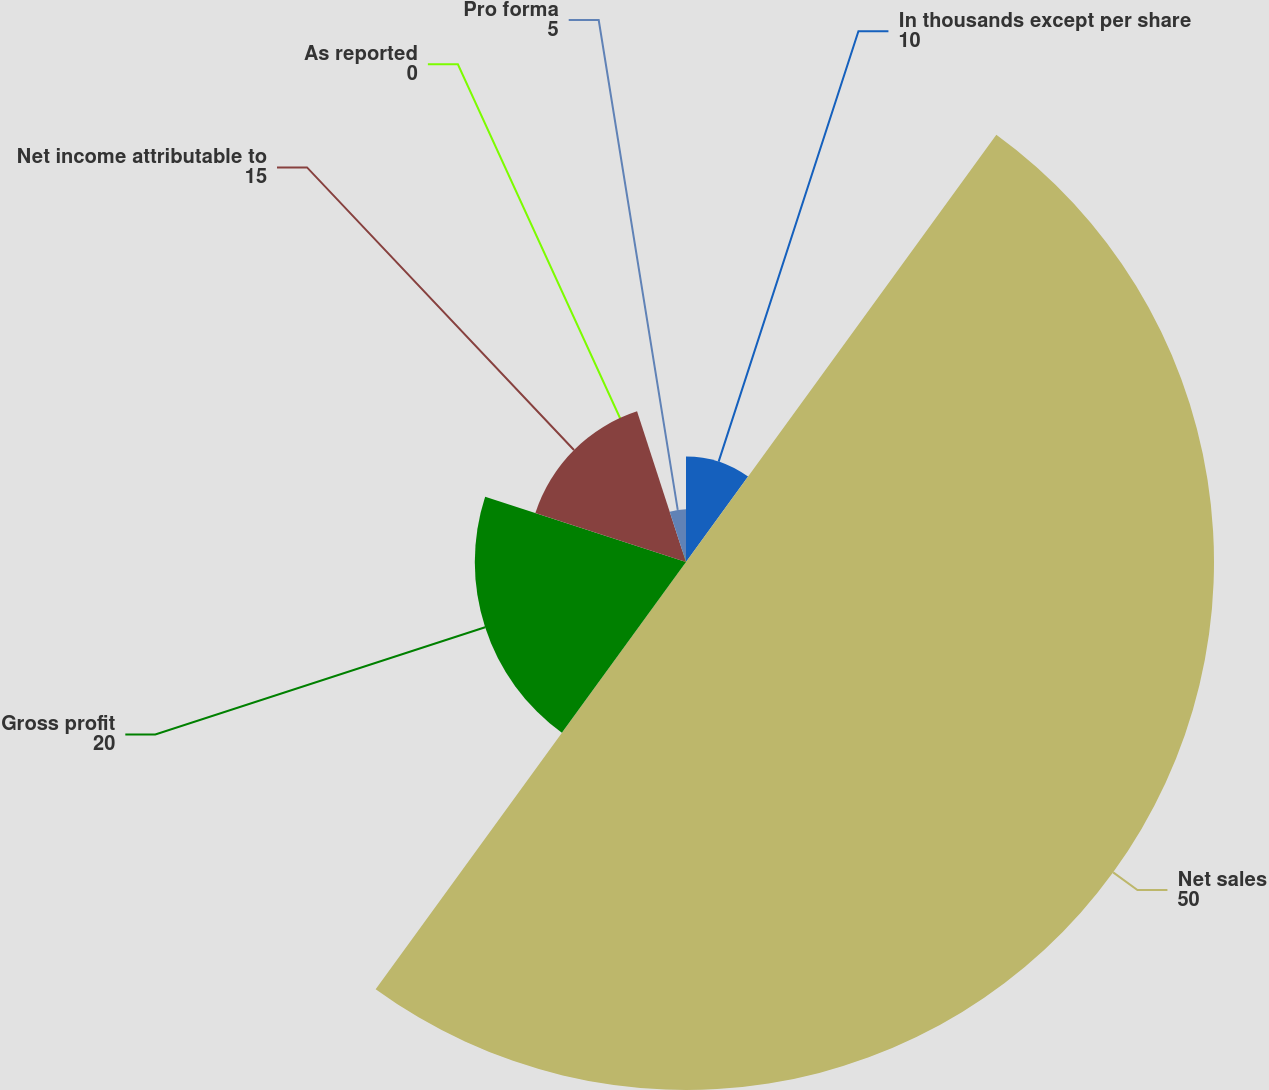Convert chart to OTSL. <chart><loc_0><loc_0><loc_500><loc_500><pie_chart><fcel>In thousands except per share<fcel>Net sales<fcel>Gross profit<fcel>Net income attributable to<fcel>As reported<fcel>Pro forma<nl><fcel>10.0%<fcel>50.0%<fcel>20.0%<fcel>15.0%<fcel>0.0%<fcel>5.0%<nl></chart> 